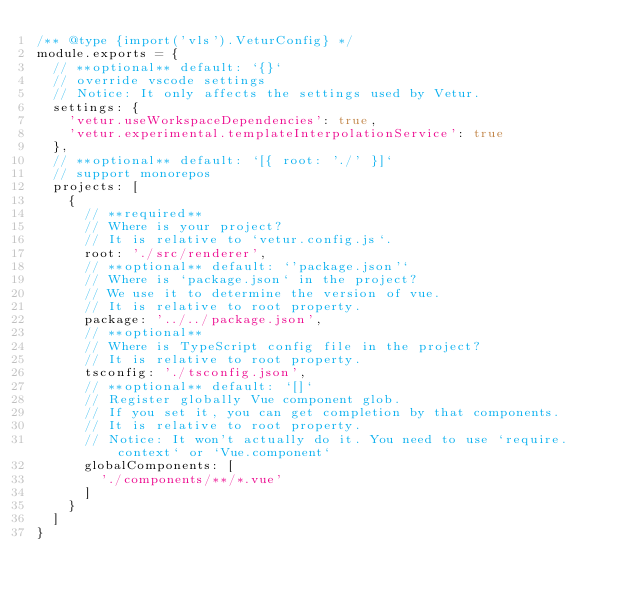<code> <loc_0><loc_0><loc_500><loc_500><_JavaScript_>/** @type {import('vls').VeturConfig} */
module.exports = {
  // **optional** default: `{}`
  // override vscode settings
  // Notice: It only affects the settings used by Vetur.
  settings: {
    'vetur.useWorkspaceDependencies': true,
    'vetur.experimental.templateInterpolationService': true
  },
  // **optional** default: `[{ root: './' }]`
  // support monorepos
  projects: [
    {
      // **required**
      // Where is your project?
      // It is relative to `vetur.config.js`.
      root: './src/renderer',
      // **optional** default: `'package.json'`
      // Where is `package.json` in the project?
      // We use it to determine the version of vue.
      // It is relative to root property.
      package: '../../package.json',
      // **optional**
      // Where is TypeScript config file in the project?
      // It is relative to root property.
      tsconfig: './tsconfig.json',
      // **optional** default: `[]`
      // Register globally Vue component glob.
      // If you set it, you can get completion by that components.
      // It is relative to root property.
      // Notice: It won't actually do it. You need to use `require.context` or `Vue.component`
      globalComponents: [
        './components/**/*.vue'
      ]
    }
  ]
}
</code> 